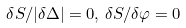<formula> <loc_0><loc_0><loc_500><loc_500>\delta S / | \delta \Delta | = 0 , \, \delta S / \delta \varphi = 0</formula> 